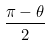Convert formula to latex. <formula><loc_0><loc_0><loc_500><loc_500>\frac { \pi - \theta } { 2 }</formula> 